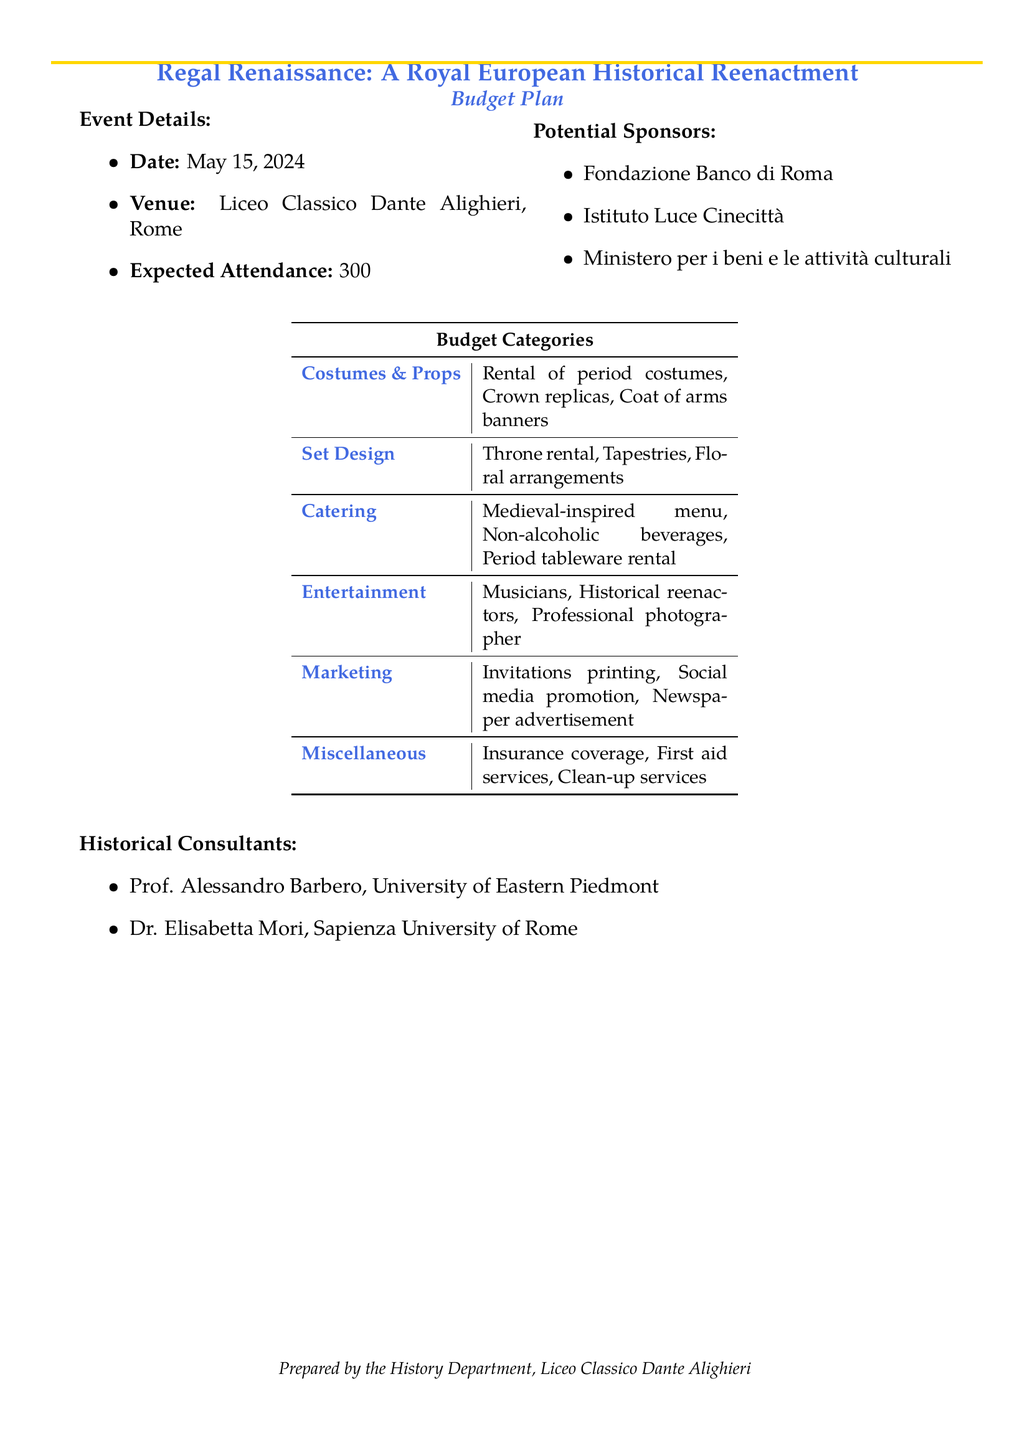what is the event date? The event date is specified in the document under "Event Details."
Answer: May 15, 2024 what is the expected attendance? The expected attendance is mentioned in the "Event Details" section.
Answer: 300 who is one of the historical consultants? The document lists historical consultants in the respective section; one of them can be noted.
Answer: Prof. Alessandro Barbero what is included in the catering budget category? The catering category lists items essential for the event, as explained in the document.
Answer: Medieval-inspired menu, Non-alcoholic beverages, Period tableware rental what are potential sponsors mentioned? The potential sponsors section provides a list of organizations that may support the event.
Answer: Fondazione Banco di Roma how many budget categories are listed? The number of budget categories is totalled based on the list in the table in the document.
Answer: 6 what is the venue for the event? The venue is specified in the "Event Details" section of the document.
Answer: Liceo Classico Dante Alighieri, Rome who contributed to the preparation of the document? The document mentions the organization that prepared the budget at the bottom.
Answer: History Department, Liceo Classico Dante Alighieri what type of entertainment is included? The entertainment category includes specific elements for the event as mentioned in the budget table.
Answer: Musicians, Historical reenactors, Professional photographer 